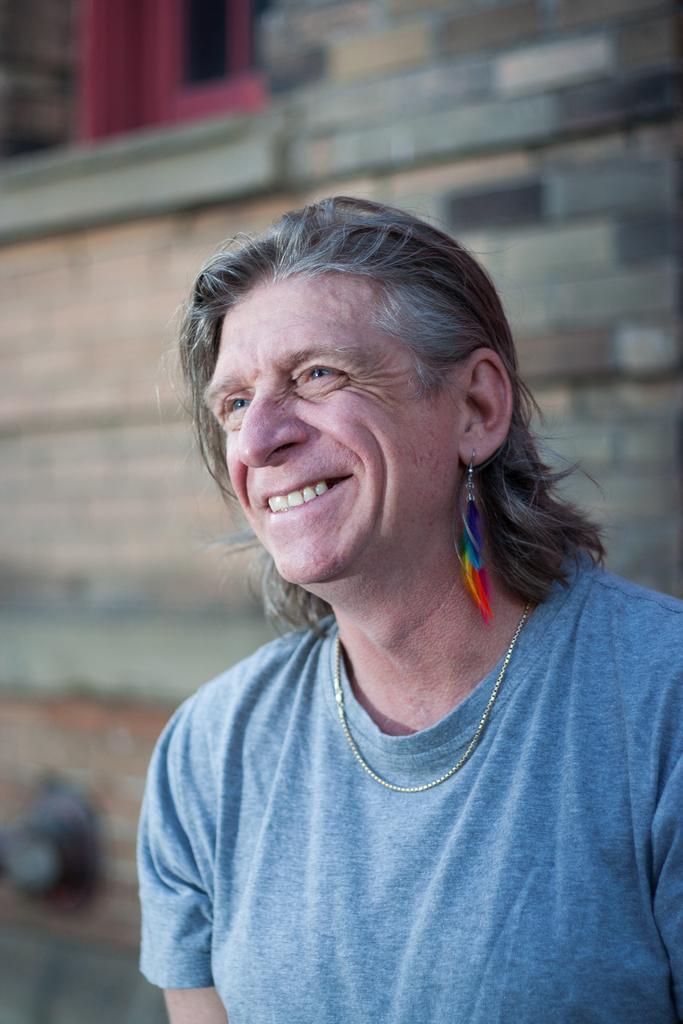Can you describe this image briefly? In this image in the front there is a person smiling. In the background there is a wall and there is a window which is red in colour. 